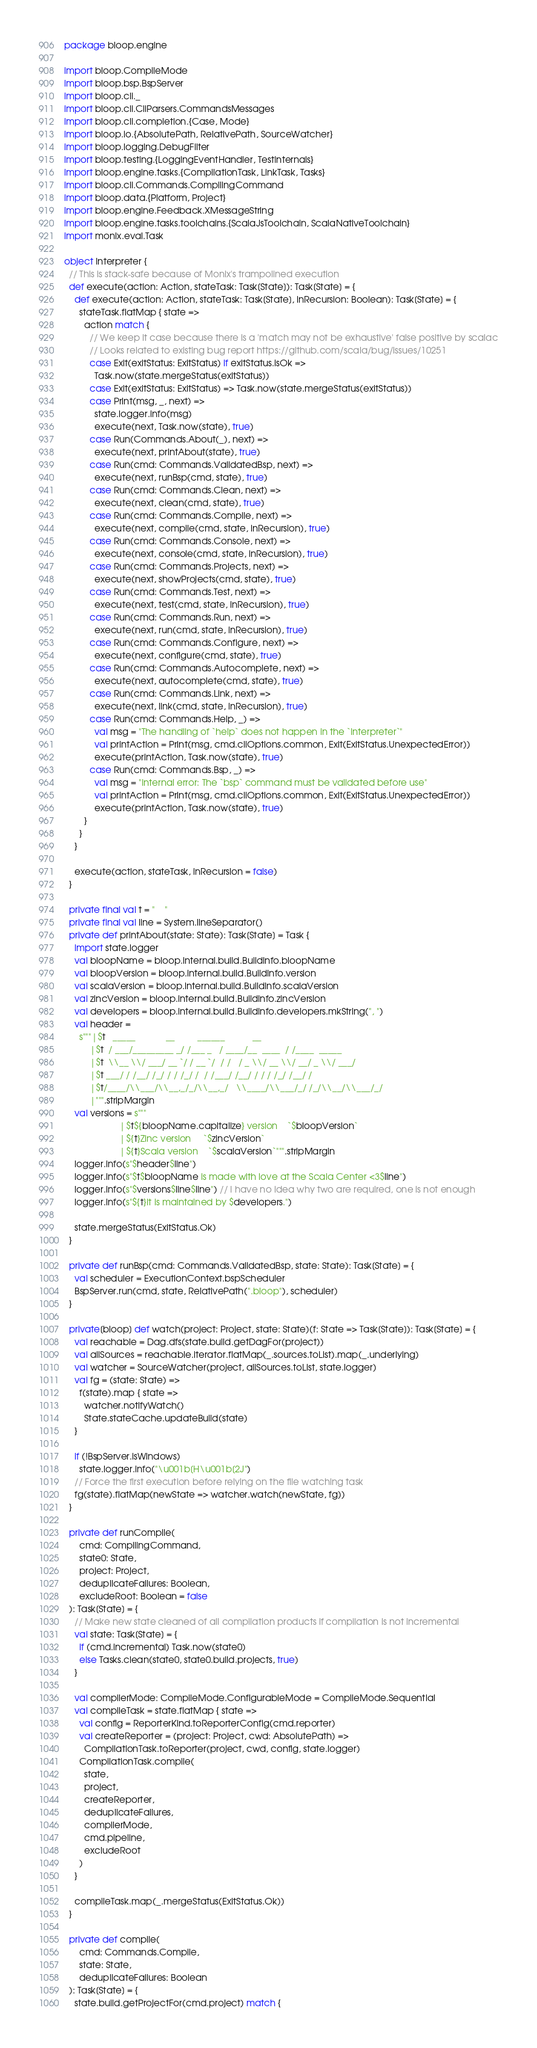Convert code to text. <code><loc_0><loc_0><loc_500><loc_500><_Scala_>package bloop.engine

import bloop.CompileMode
import bloop.bsp.BspServer
import bloop.cli._
import bloop.cli.CliParsers.CommandsMessages
import bloop.cli.completion.{Case, Mode}
import bloop.io.{AbsolutePath, RelativePath, SourceWatcher}
import bloop.logging.DebugFilter
import bloop.testing.{LoggingEventHandler, TestInternals}
import bloop.engine.tasks.{CompilationTask, LinkTask, Tasks}
import bloop.cli.Commands.CompilingCommand
import bloop.data.{Platform, Project}
import bloop.engine.Feedback.XMessageString
import bloop.engine.tasks.toolchains.{ScalaJsToolchain, ScalaNativeToolchain}
import monix.eval.Task

object Interpreter {
  // This is stack-safe because of Monix's trampolined execution
  def execute(action: Action, stateTask: Task[State]): Task[State] = {
    def execute(action: Action, stateTask: Task[State], inRecursion: Boolean): Task[State] = {
      stateTask.flatMap { state =>
        action match {
          // We keep it case because there is a 'match may not be exhaustive' false positive by scalac
          // Looks related to existing bug report https://github.com/scala/bug/issues/10251
          case Exit(exitStatus: ExitStatus) if exitStatus.isOk =>
            Task.now(state.mergeStatus(exitStatus))
          case Exit(exitStatus: ExitStatus) => Task.now(state.mergeStatus(exitStatus))
          case Print(msg, _, next) =>
            state.logger.info(msg)
            execute(next, Task.now(state), true)
          case Run(Commands.About(_), next) =>
            execute(next, printAbout(state), true)
          case Run(cmd: Commands.ValidatedBsp, next) =>
            execute(next, runBsp(cmd, state), true)
          case Run(cmd: Commands.Clean, next) =>
            execute(next, clean(cmd, state), true)
          case Run(cmd: Commands.Compile, next) =>
            execute(next, compile(cmd, state, inRecursion), true)
          case Run(cmd: Commands.Console, next) =>
            execute(next, console(cmd, state, inRecursion), true)
          case Run(cmd: Commands.Projects, next) =>
            execute(next, showProjects(cmd, state), true)
          case Run(cmd: Commands.Test, next) =>
            execute(next, test(cmd, state, inRecursion), true)
          case Run(cmd: Commands.Run, next) =>
            execute(next, run(cmd, state, inRecursion), true)
          case Run(cmd: Commands.Configure, next) =>
            execute(next, configure(cmd, state), true)
          case Run(cmd: Commands.Autocomplete, next) =>
            execute(next, autocomplete(cmd, state), true)
          case Run(cmd: Commands.Link, next) =>
            execute(next, link(cmd, state, inRecursion), true)
          case Run(cmd: Commands.Help, _) =>
            val msg = "The handling of `help` does not happen in the `Interpreter`"
            val printAction = Print(msg, cmd.cliOptions.common, Exit(ExitStatus.UnexpectedError))
            execute(printAction, Task.now(state), true)
          case Run(cmd: Commands.Bsp, _) =>
            val msg = "Internal error: The `bsp` command must be validated before use"
            val printAction = Print(msg, cmd.cliOptions.common, Exit(ExitStatus.UnexpectedError))
            execute(printAction, Task.now(state), true)
        }
      }
    }

    execute(action, stateTask, inRecursion = false)
  }

  private final val t = "    "
  private final val line = System.lineSeparator()
  private def printAbout(state: State): Task[State] = Task {
    import state.logger
    val bloopName = bloop.internal.build.BuildInfo.bloopName
    val bloopVersion = bloop.internal.build.BuildInfo.version
    val scalaVersion = bloop.internal.build.BuildInfo.scalaVersion
    val zincVersion = bloop.internal.build.BuildInfo.zincVersion
    val developers = bloop.internal.build.BuildInfo.developers.mkString(", ")
    val header =
      s"""|$t   _____            __         ______           __
          |$t  / ___/_________ _/ /___ _   / ____/__  ____  / /____  _____
          |$t  \\__ \\/ ___/ __ `/ / __ `/  / /   / _ \\/ __ \\/ __/ _ \\/ ___/
          |$t ___/ / /__/ /_/ / / /_/ /  / /___/ /__/ / / / /_/ /__/ /
          |$t/____/\\___/\\__,_/_/\\__,_/   \\____/\\___/_/ /_/\\__/\\___/_/
          |""".stripMargin
    val versions = s"""
                      |$t${bloopName.capitalize} version    `$bloopVersion`
                      |${t}Zinc version     `$zincVersion`
                      |${t}Scala version    `$scalaVersion`""".stripMargin
    logger.info(s"$header$line")
    logger.info(s"$t$bloopName is made with love at the Scala Center <3$line")
    logger.info(s"$versions$line$line") // I have no idea why two are required, one is not enough
    logger.info(s"${t}It is maintained by $developers.")

    state.mergeStatus(ExitStatus.Ok)
  }

  private def runBsp(cmd: Commands.ValidatedBsp, state: State): Task[State] = {
    val scheduler = ExecutionContext.bspScheduler
    BspServer.run(cmd, state, RelativePath(".bloop"), scheduler)
  }

  private[bloop] def watch(project: Project, state: State)(f: State => Task[State]): Task[State] = {
    val reachable = Dag.dfs(state.build.getDagFor(project))
    val allSources = reachable.iterator.flatMap(_.sources.toList).map(_.underlying)
    val watcher = SourceWatcher(project, allSources.toList, state.logger)
    val fg = (state: State) =>
      f(state).map { state =>
        watcher.notifyWatch()
        State.stateCache.updateBuild(state)
    }

    if (!BspServer.isWindows)
      state.logger.info("\u001b[H\u001b[2J")
    // Force the first execution before relying on the file watching task
    fg(state).flatMap(newState => watcher.watch(newState, fg))
  }

  private def runCompile(
      cmd: CompilingCommand,
      state0: State,
      project: Project,
      deduplicateFailures: Boolean,
      excludeRoot: Boolean = false
  ): Task[State] = {
    // Make new state cleaned of all compilation products if compilation is not incremental
    val state: Task[State] = {
      if (cmd.incremental) Task.now(state0)
      else Tasks.clean(state0, state0.build.projects, true)
    }

    val compilerMode: CompileMode.ConfigurableMode = CompileMode.Sequential
    val compileTask = state.flatMap { state =>
      val config = ReporterKind.toReporterConfig(cmd.reporter)
      val createReporter = (project: Project, cwd: AbsolutePath) =>
        CompilationTask.toReporter(project, cwd, config, state.logger)
      CompilationTask.compile(
        state,
        project,
        createReporter,
        deduplicateFailures,
        compilerMode,
        cmd.pipeline,
        excludeRoot
      )
    }

    compileTask.map(_.mergeStatus(ExitStatus.Ok))
  }

  private def compile(
      cmd: Commands.Compile,
      state: State,
      deduplicateFailures: Boolean
  ): Task[State] = {
    state.build.getProjectFor(cmd.project) match {</code> 